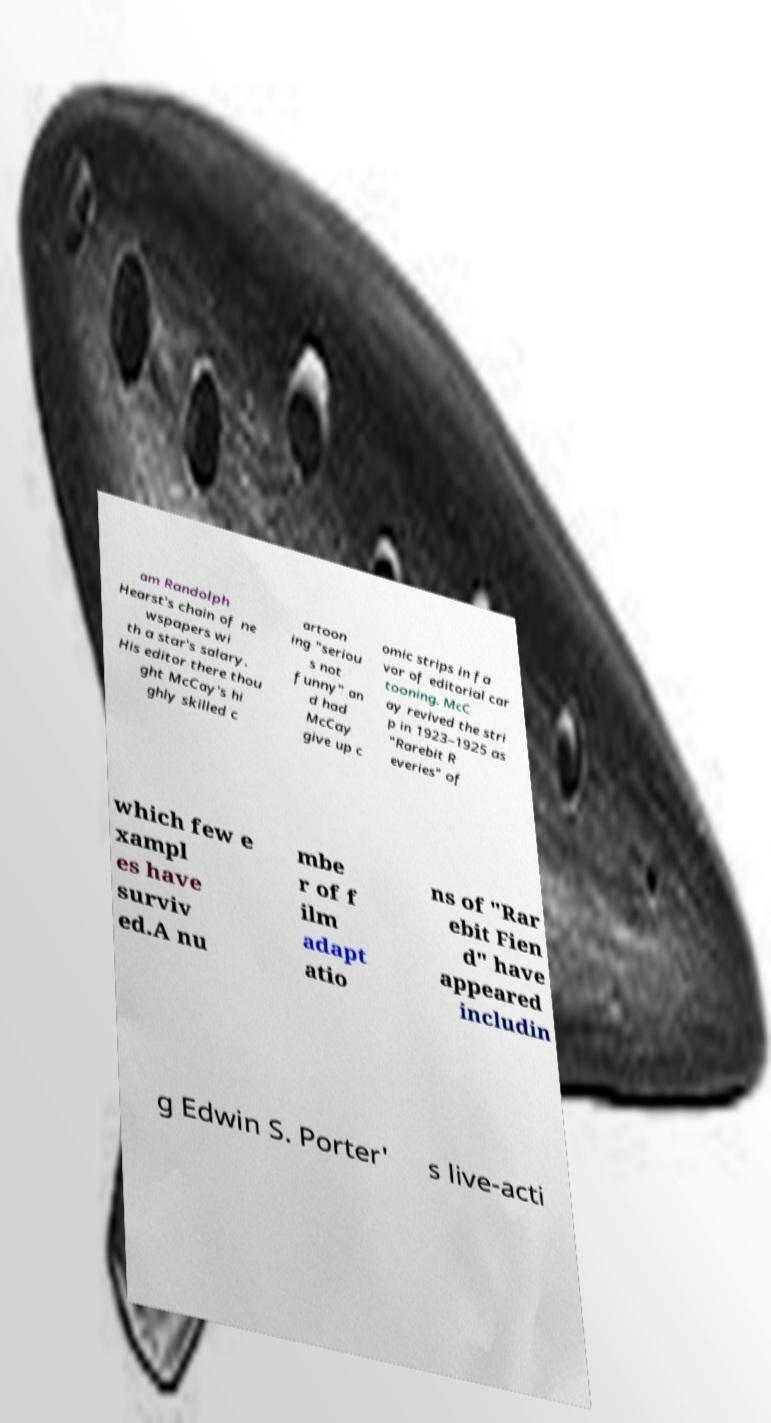Can you accurately transcribe the text from the provided image for me? am Randolph Hearst's chain of ne wspapers wi th a star's salary. His editor there thou ght McCay's hi ghly skilled c artoon ing "seriou s not funny" an d had McCay give up c omic strips in fa vor of editorial car tooning. McC ay revived the stri p in 1923–1925 as "Rarebit R everies" of which few e xampl es have surviv ed.A nu mbe r of f ilm adapt atio ns of "Rar ebit Fien d" have appeared includin g Edwin S. Porter' s live-acti 